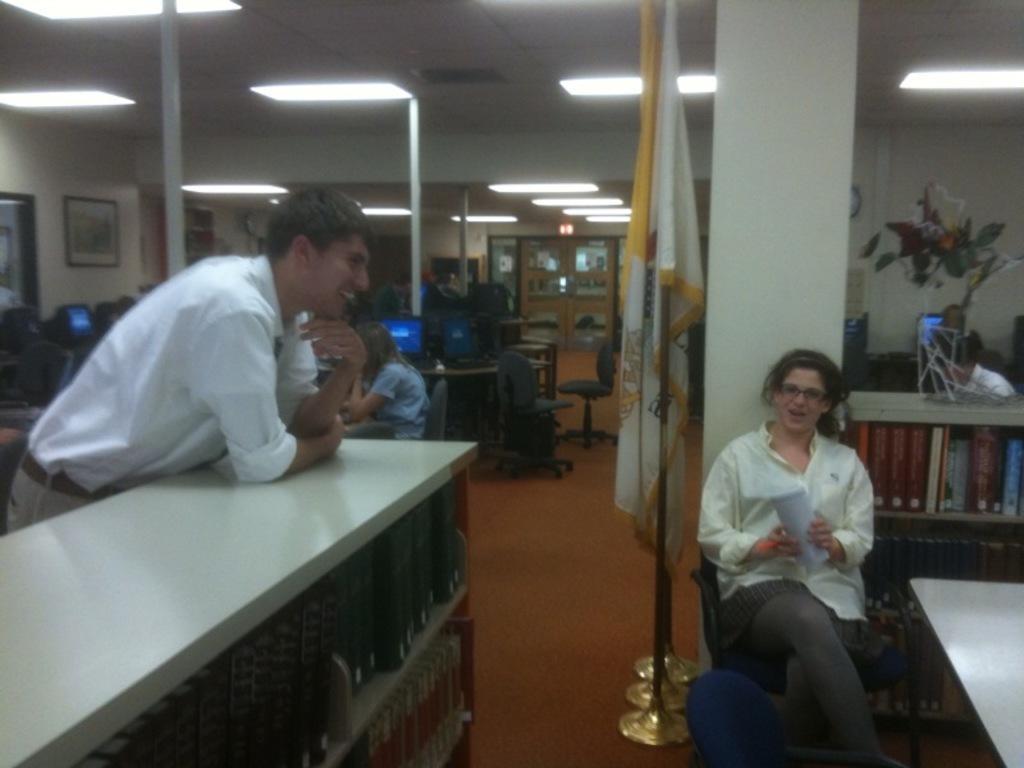Describe this image in one or two sentences. In this image, In the left side there is a table which is in white color, There is a man standing at the table, In the right side there is a girl sitting on the chair, There is a flag which is in yellow and white color, In the background there is a white color and there is a artificial flower box on the table. 